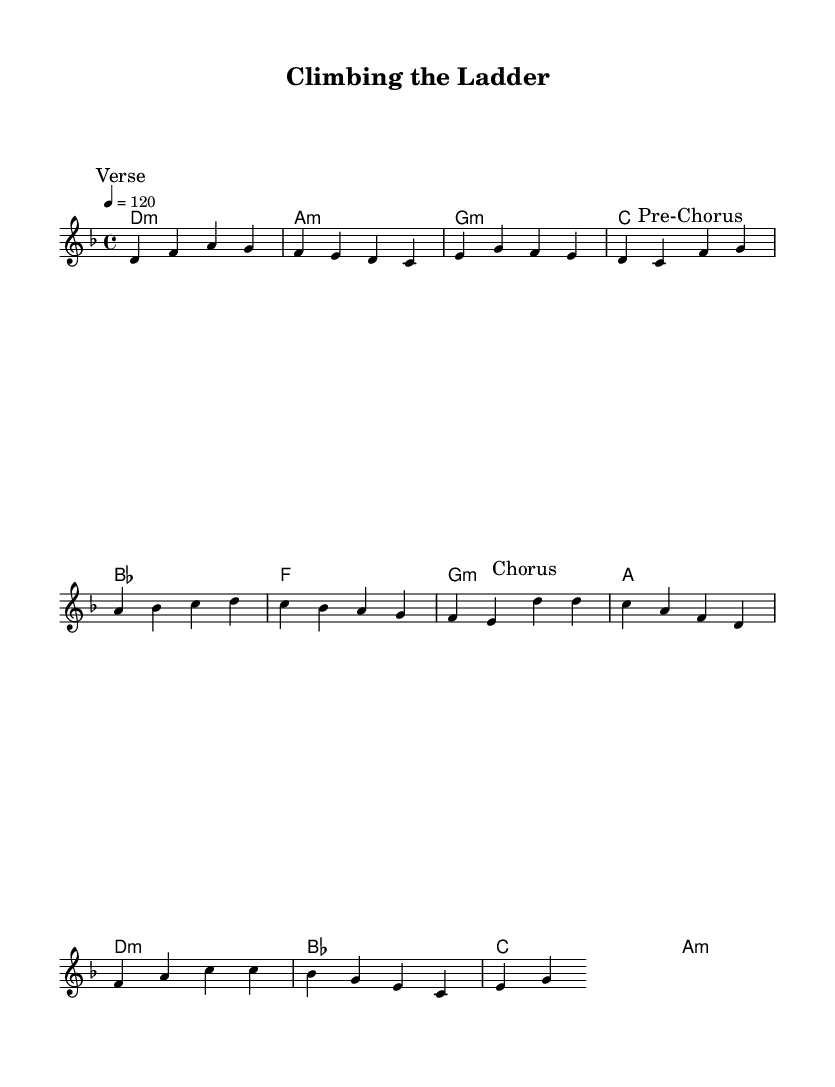What is the key signature of this music? The key signature is D minor, indicated by the presence of one flat (B flat) at the beginning of the staff. This can be confirmed by looking at the key signature markers at the start of the music.
Answer: D minor What is the time signature of this music? The time signature is 4/4, which is indicated in the music sheet. This means there are four beats in each measure, and the quarter note receives one beat. This can be found right after the key signature.
Answer: 4/4 What is the tempo marking for this piece? The tempo marking is 120 beats per minute, which is specified in the score as "4 = 120." This denotes the speed at which the music should be played, indicated by the tempo instructions at the beginning of the score.
Answer: 120 How many measures are in the chorus section? The chorus consists of 4 measures. This can be determined by counting the bar lines and visualizing the section labeled "Chorus," which contains 4 distinct measures.
Answer: 4 What is the first chord in the piece? The first chord is D minor. This can be deduced from the first chord listed in the chord section, which corresponds to the first measure of the melody.
Answer: D minor What type of musical section is marked after the verse? The section marked after the verse is a pre-chorus. This is labeled clearly in the music sheet and indicates a transition from the verse to the upcoming chorus.
Answer: Pre-Chorus Which chord follows the A minor chord in the harmonies? The chord that follows the A minor chord is D minor. This can be seen by looking at the chord progressions in the harmonies section, where A minor is followed directly by D minor.
Answer: D minor 